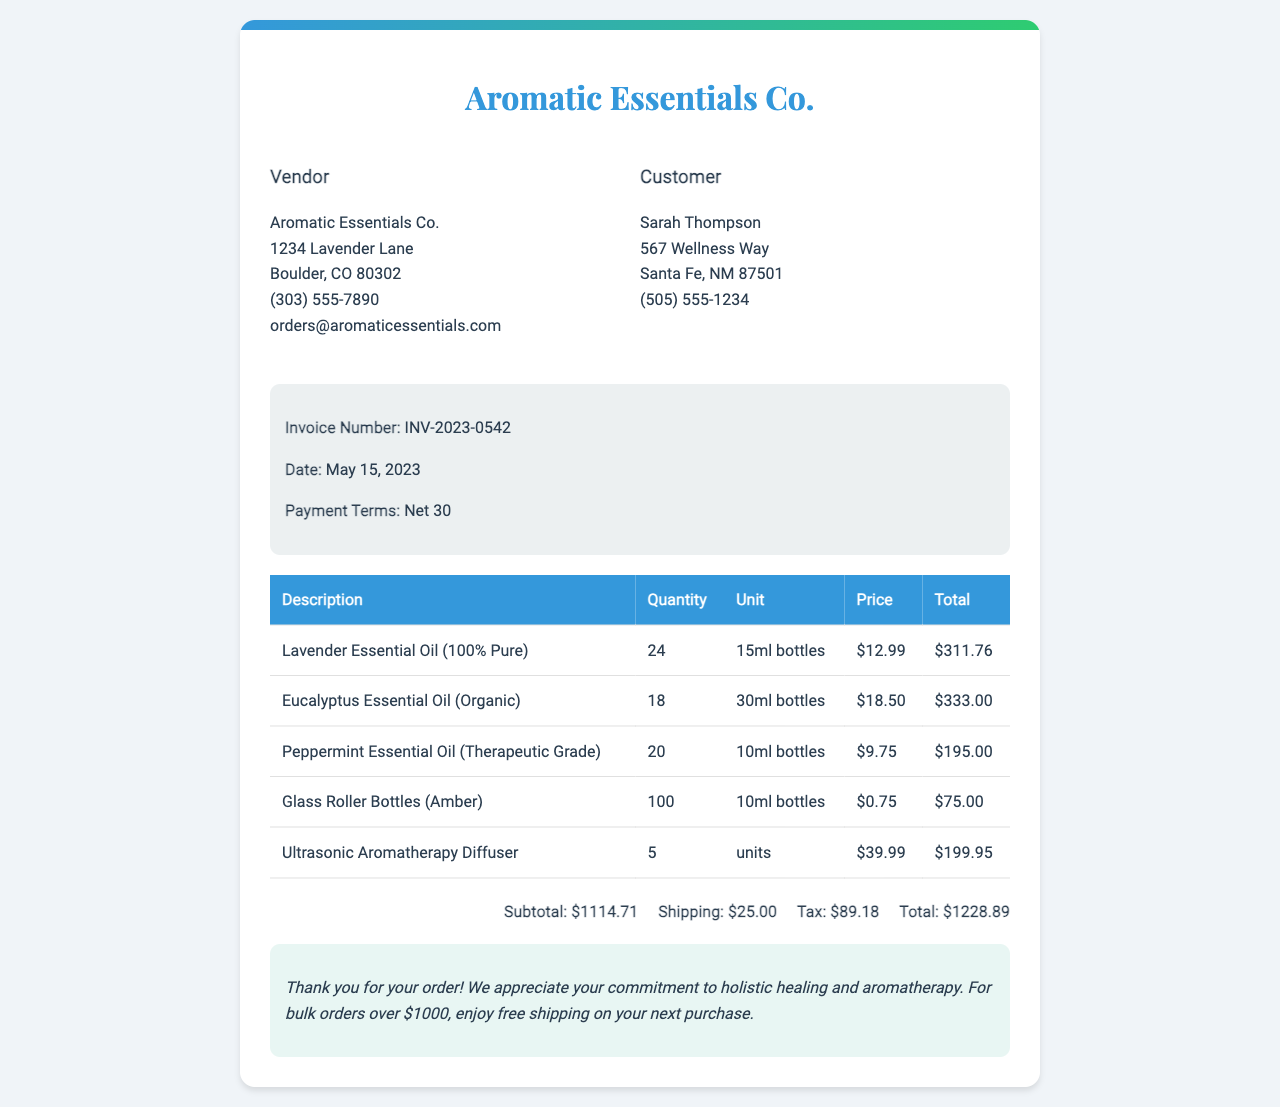What is the invoice number? The invoice number is a unique identifier for the order, listed in the document.
Answer: INV-2023-0542 Who is the customer? The customer details are provided in the document, which includes their name and address.
Answer: Sarah Thompson What is the shipping cost? The shipping cost is explicitly mentioned in the document under the total section.
Answer: $25.00 How many units of Ultrasonic Aromatherapy Diffuser are ordered? The quantity of Ultrasonic Aromatherapy Diffuser is stated in the order details section of the document.
Answer: 5 What is the total amount due? The total amount due includes the subtotal, shipping, and tax as calculated in the invoice.
Answer: $1228.89 Which essential oil has the highest price per unit? This question requires comparing the unit prices given for different essential oils in the document.
Answer: Eucalyptus Essential Oil (Organic) What is the date of the invoice? The date when the invoice was generated is provided in the document.
Answer: May 15, 2023 What is the payment term specified? The payment terms provide information on when the payment is due after the invoice date.
Answer: Net 30 What type of bottles are included in the order? The type of bottles ordered is specified in the document and refers to a specific product category.
Answer: Glass Roller Bottles (Amber) 